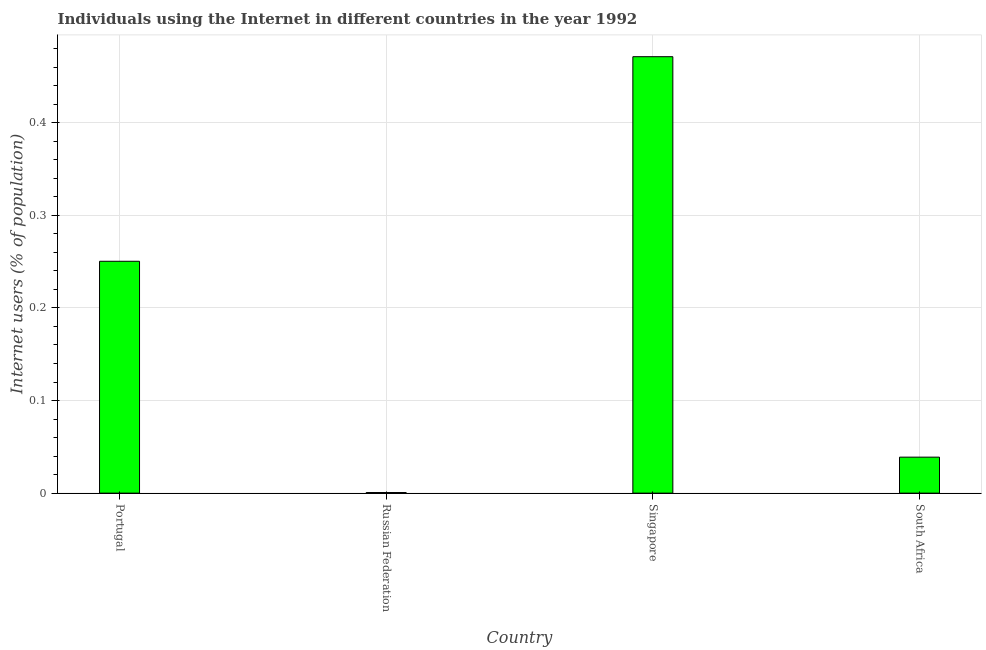Does the graph contain any zero values?
Provide a short and direct response. No. What is the title of the graph?
Provide a succinct answer. Individuals using the Internet in different countries in the year 1992. What is the label or title of the X-axis?
Provide a succinct answer. Country. What is the label or title of the Y-axis?
Provide a short and direct response. Internet users (% of population). What is the number of internet users in South Africa?
Provide a short and direct response. 0.04. Across all countries, what is the maximum number of internet users?
Offer a very short reply. 0.47. Across all countries, what is the minimum number of internet users?
Offer a terse response. 0. In which country was the number of internet users maximum?
Your answer should be very brief. Singapore. In which country was the number of internet users minimum?
Your answer should be compact. Russian Federation. What is the sum of the number of internet users?
Your answer should be very brief. 0.76. What is the difference between the number of internet users in Portugal and Singapore?
Provide a short and direct response. -0.22. What is the average number of internet users per country?
Your answer should be very brief. 0.19. What is the median number of internet users?
Your response must be concise. 0.14. What is the ratio of the number of internet users in Portugal to that in Singapore?
Provide a succinct answer. 0.53. Is the number of internet users in Portugal less than that in South Africa?
Ensure brevity in your answer.  No. Is the difference between the number of internet users in Singapore and South Africa greater than the difference between any two countries?
Make the answer very short. No. What is the difference between the highest and the second highest number of internet users?
Provide a short and direct response. 0.22. What is the difference between the highest and the lowest number of internet users?
Your answer should be compact. 0.47. In how many countries, is the number of internet users greater than the average number of internet users taken over all countries?
Give a very brief answer. 2. How many bars are there?
Your answer should be very brief. 4. How many countries are there in the graph?
Provide a succinct answer. 4. Are the values on the major ticks of Y-axis written in scientific E-notation?
Your response must be concise. No. What is the Internet users (% of population) of Portugal?
Your response must be concise. 0.25. What is the Internet users (% of population) in Russian Federation?
Ensure brevity in your answer.  0. What is the Internet users (% of population) of Singapore?
Offer a terse response. 0.47. What is the Internet users (% of population) of South Africa?
Your answer should be compact. 0.04. What is the difference between the Internet users (% of population) in Portugal and Russian Federation?
Give a very brief answer. 0.25. What is the difference between the Internet users (% of population) in Portugal and Singapore?
Keep it short and to the point. -0.22. What is the difference between the Internet users (% of population) in Portugal and South Africa?
Keep it short and to the point. 0.21. What is the difference between the Internet users (% of population) in Russian Federation and Singapore?
Your answer should be compact. -0.47. What is the difference between the Internet users (% of population) in Russian Federation and South Africa?
Keep it short and to the point. -0.04. What is the difference between the Internet users (% of population) in Singapore and South Africa?
Your answer should be very brief. 0.43. What is the ratio of the Internet users (% of population) in Portugal to that in Russian Federation?
Provide a succinct answer. 372.36. What is the ratio of the Internet users (% of population) in Portugal to that in Singapore?
Offer a terse response. 0.53. What is the ratio of the Internet users (% of population) in Portugal to that in South Africa?
Offer a terse response. 6.44. What is the ratio of the Internet users (% of population) in Russian Federation to that in South Africa?
Provide a succinct answer. 0.02. What is the ratio of the Internet users (% of population) in Singapore to that in South Africa?
Give a very brief answer. 12.13. 